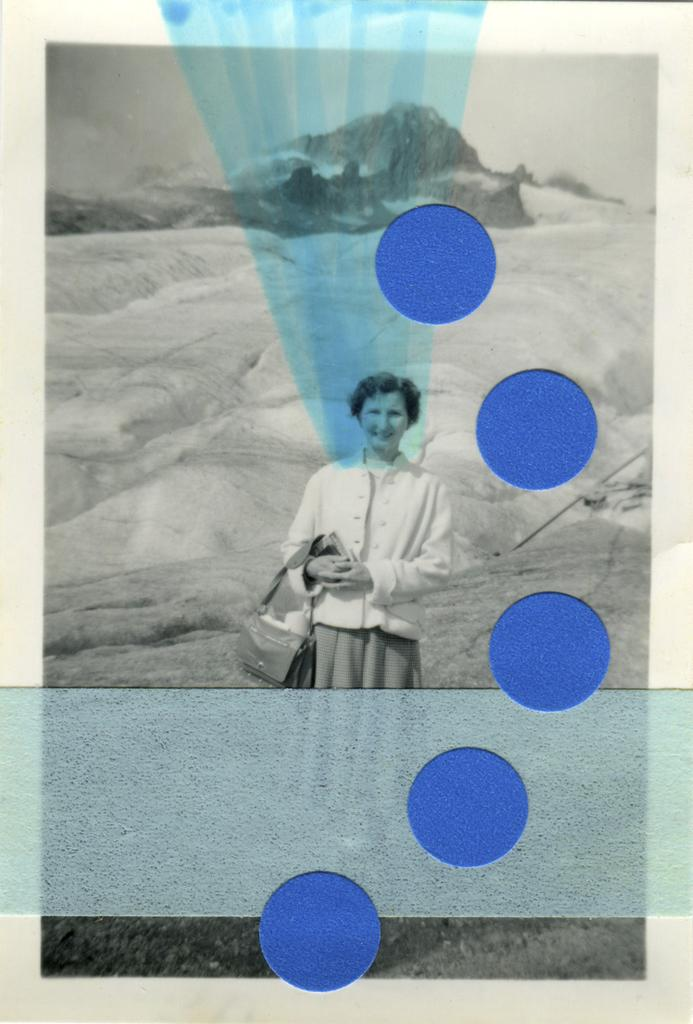What is the person in the image doing? The person is standing in the image. What is the person holding in the image? The person is holding a bag. What can be seen in the distance in the image? There is a mountain visible in the background of the image. What color are the dots in the image? The image is in black and white, so there are no colored dots. However, there are blue dots mentioned in the facts, which would appear as shades of gray in the image. What type of lamp is on the table next to the person in the image? There is no lamp present in the image. What treatment is the person undergoing in the image? There is no indication of any treatment in the image; it simply shows a person standing with a bag. 